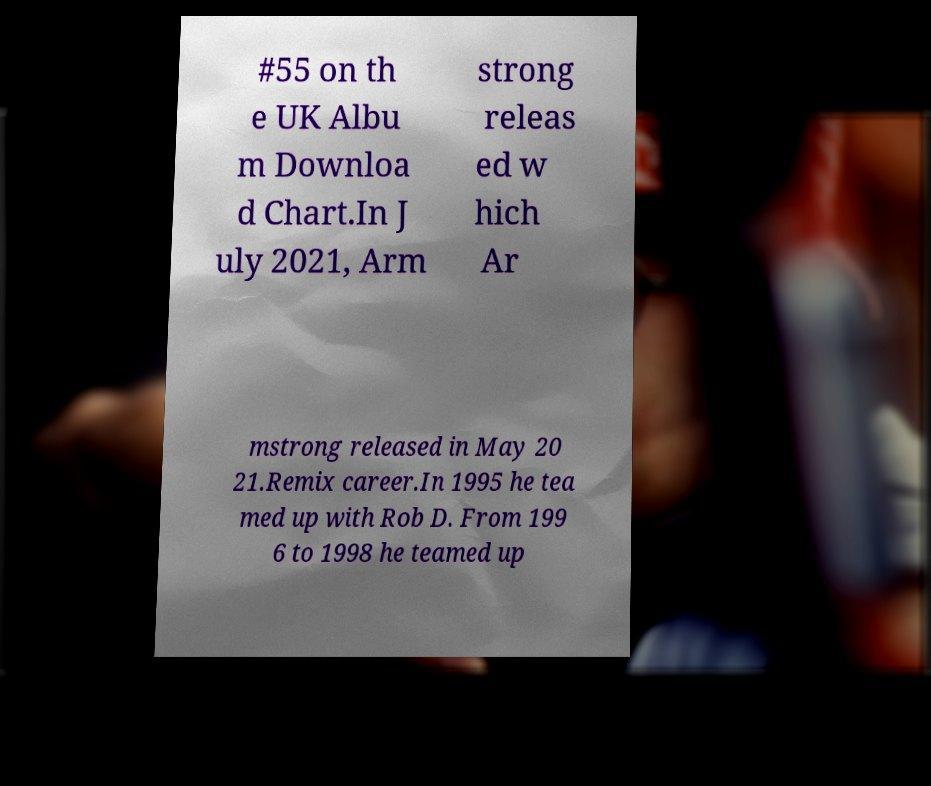What messages or text are displayed in this image? I need them in a readable, typed format. #55 on th e UK Albu m Downloa d Chart.In J uly 2021, Arm strong releas ed w hich Ar mstrong released in May 20 21.Remix career.In 1995 he tea med up with Rob D. From 199 6 to 1998 he teamed up 